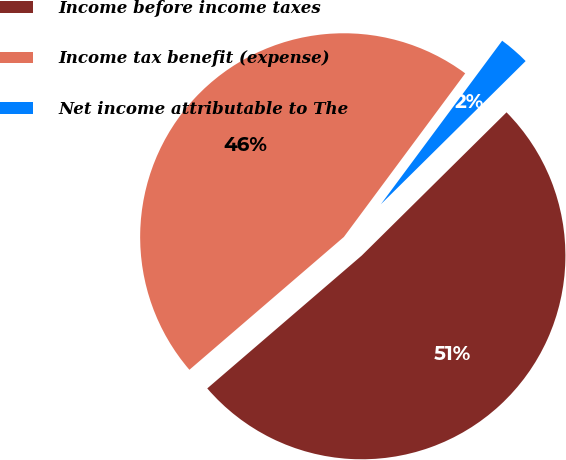Convert chart. <chart><loc_0><loc_0><loc_500><loc_500><pie_chart><fcel>Income before income taxes<fcel>Income tax benefit (expense)<fcel>Net income attributable to The<nl><fcel>51.11%<fcel>46.46%<fcel>2.43%<nl></chart> 